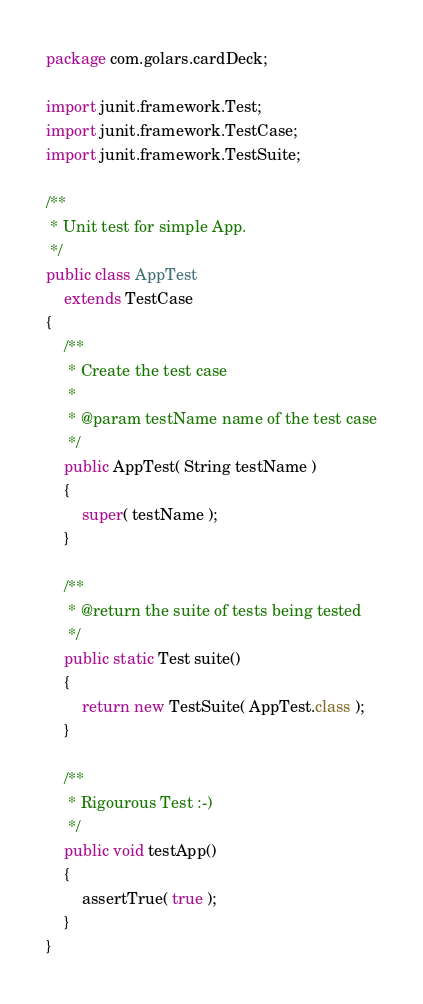Convert code to text. <code><loc_0><loc_0><loc_500><loc_500><_Java_>package com.golars.cardDeck;

import junit.framework.Test;
import junit.framework.TestCase;
import junit.framework.TestSuite;

/**
 * Unit test for simple App.
 */
public class AppTest 
    extends TestCase
{
    /**
     * Create the test case
     *
     * @param testName name of the test case
     */
    public AppTest( String testName )
    {
        super( testName );
    }

    /**
     * @return the suite of tests being tested
     */
    public static Test suite()
    {
        return new TestSuite( AppTest.class );
    }

    /**
     * Rigourous Test :-)
     */
    public void testApp()
    {
        assertTrue( true );
    }
}
</code> 